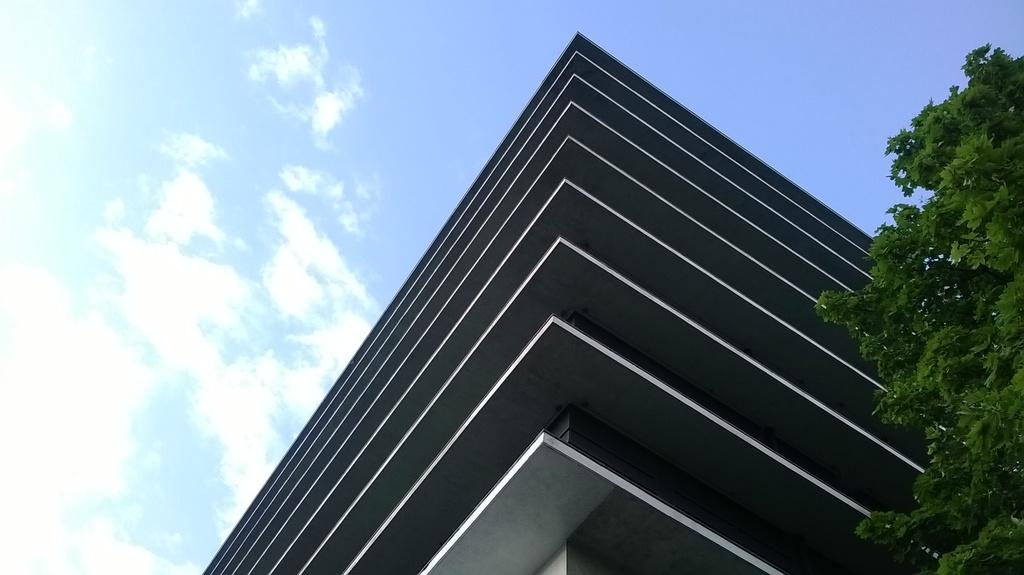What type of building is in the image? There is a grey-colored building in the image. What can be seen on the right side of the image? There is a tree on the right side of the image. What is present on the left side of the image? There are clouds on the left side of the image. What is visible at the top of the image? The sky is visible at the top of the image. What color is the sky in the image? The sky is blue in color. How does the daughter react to the earthquake in the image? There is no daughter or earthquake present in the image. 